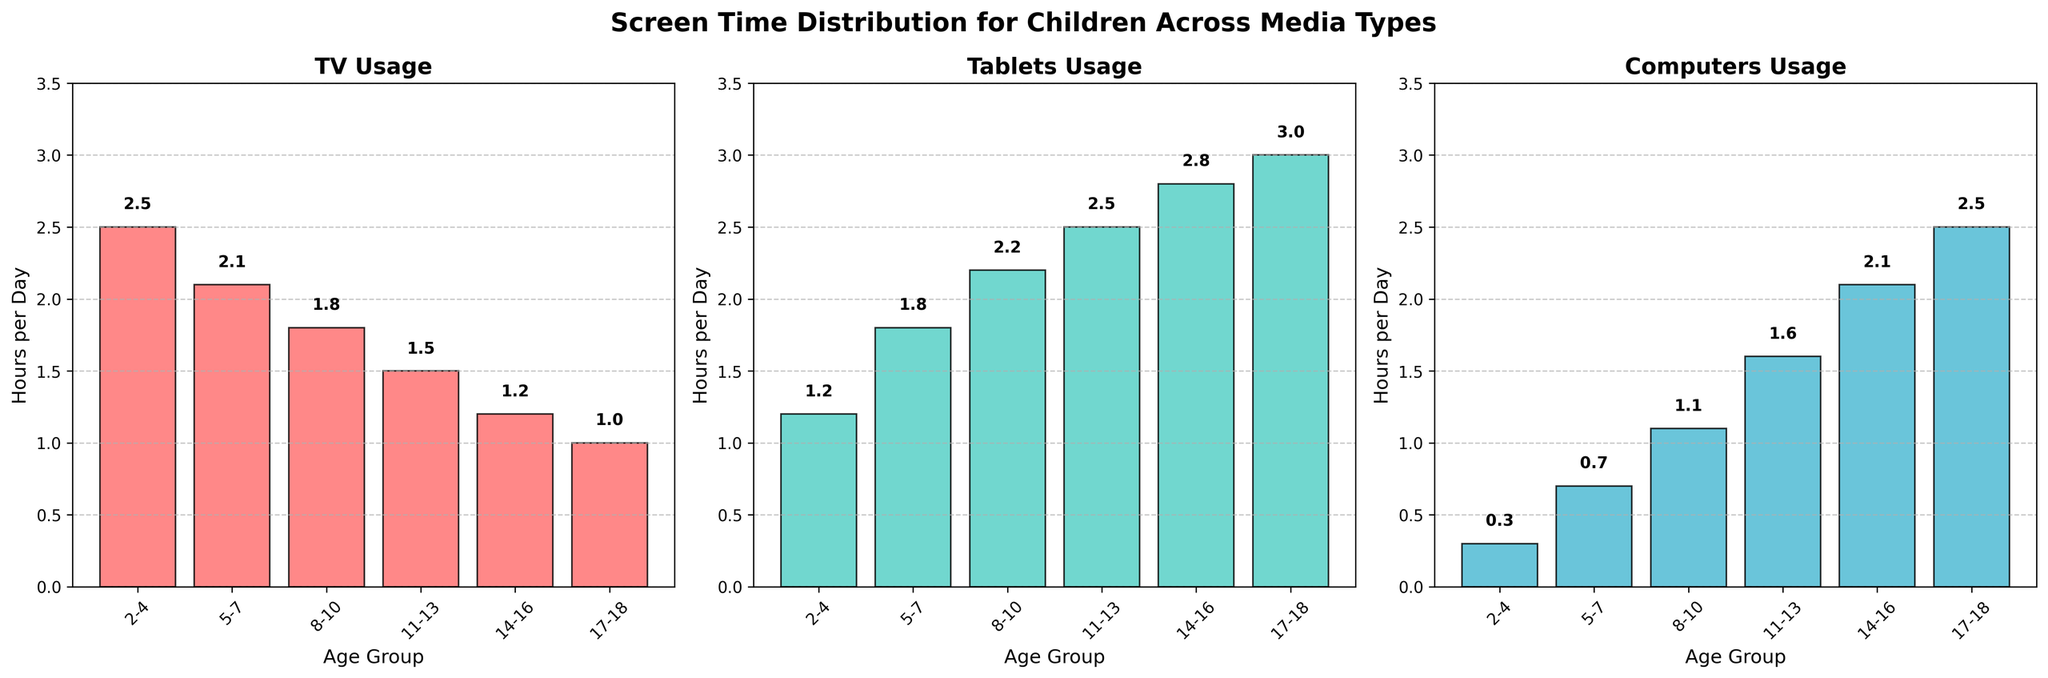Which age group has the highest TV usage? By observing the TV bar chart, the tallest bar represents the 2-4 age group. We can directly note that this group has the highest TV usage.
Answer: 2-4 For which age group is computer usage the highest? From the computer bar chart, the tallest bar is associated with the 17-18 age group, indicating it has the highest computer usage.
Answer: 17-18 Is tablet usage consistently increasing with age? Tablet usage can be observed increasing in height for each subsequent age group in the tablet bar chart. Thus, it consistently increases with age.
Answer: Yes Compare the TV usage between the 5-7 and 8-10 age groups. Which one is greater? By comparing the heights of the bars for the 5-7 and 8-10 age groups in the TV chart, the 5-7 age group has a taller bar (2.1) than the 8-10 age group (1.8).
Answer: 5-7 Which age group has the most balanced screen usage across TV, tablets, and computers? By viewing all three charts, the 8-10 age group has comparatively closer values: TV (1.8), Tablets (2.2), Computers (1.1), indicating balanced usage.
Answer: 8-10 What is the total screen time per day for the 14-16 age group across all types of media? Adding up the screen times from TV (1.2), tablets (2.8), and computers (2.1), we get 1.2 + 2.8 + 2.1 = 6.1 hours per day.
Answer: 6.1 hours Is there any age group where the computer usage is higher than TV usage? By comparing each age group's bars in the TV and computer charts, the 14-16 and 17-18 age groups have higher computer usage compared to their TV usage.
Answer: Yes What is the difference in tablet usage between the 8-10 and 17-18 age groups? Subtracting the tablet usage of the 8-10 age group (2.2) from the 17-18 age group (3.0), we get 3.0 - 2.2 = 0.8 hours.
Answer: 0.8 hours How much does TV usage decrease from the 2-4 age group to the 17-18 age group? Subtracting the TV usage of the 17-18 group (1.0) from the 2-4 group (2.5), we get 2.5 - 1.0 = 1.5 hours.
Answer: 1.5 hours 